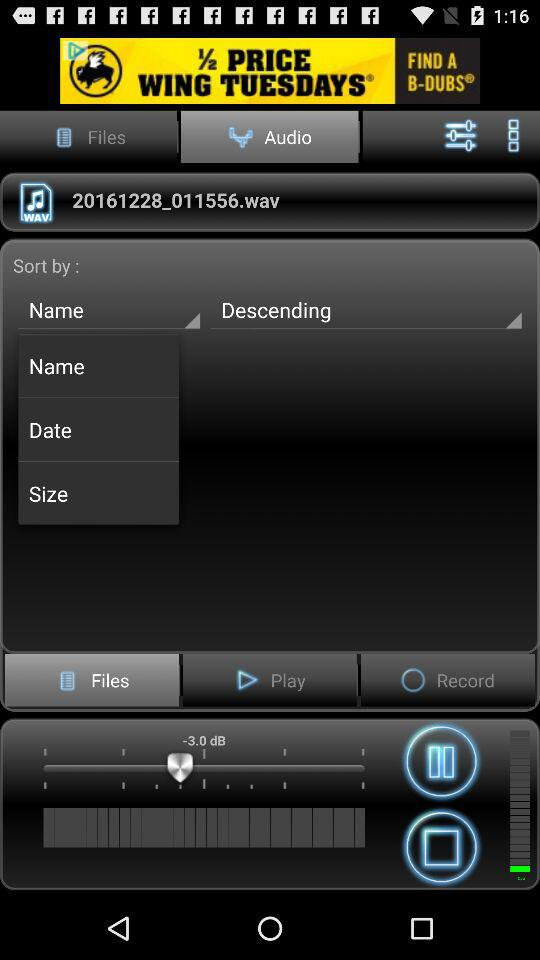How are the audios sorted? The audios are sorted by name in descending order. 